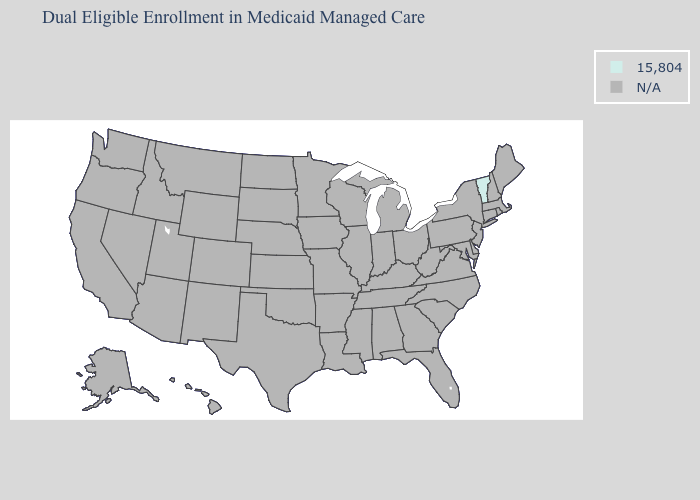Name the states that have a value in the range 15,804?
Be succinct. Vermont. Is the legend a continuous bar?
Give a very brief answer. No. Name the states that have a value in the range 15,804?
Be succinct. Vermont. Name the states that have a value in the range N/A?
Write a very short answer. Alabama, Alaska, Arizona, Arkansas, California, Colorado, Connecticut, Delaware, Florida, Georgia, Hawaii, Idaho, Illinois, Indiana, Iowa, Kansas, Kentucky, Louisiana, Maine, Maryland, Massachusetts, Michigan, Minnesota, Mississippi, Missouri, Montana, Nebraska, Nevada, New Hampshire, New Jersey, New Mexico, New York, North Carolina, North Dakota, Ohio, Oklahoma, Oregon, Pennsylvania, Rhode Island, South Carolina, South Dakota, Tennessee, Texas, Utah, Virginia, Washington, West Virginia, Wisconsin, Wyoming. Name the states that have a value in the range N/A?
Answer briefly. Alabama, Alaska, Arizona, Arkansas, California, Colorado, Connecticut, Delaware, Florida, Georgia, Hawaii, Idaho, Illinois, Indiana, Iowa, Kansas, Kentucky, Louisiana, Maine, Maryland, Massachusetts, Michigan, Minnesota, Mississippi, Missouri, Montana, Nebraska, Nevada, New Hampshire, New Jersey, New Mexico, New York, North Carolina, North Dakota, Ohio, Oklahoma, Oregon, Pennsylvania, Rhode Island, South Carolina, South Dakota, Tennessee, Texas, Utah, Virginia, Washington, West Virginia, Wisconsin, Wyoming. What is the value of New York?
Concise answer only. N/A. What is the value of Maine?
Concise answer only. N/A. 